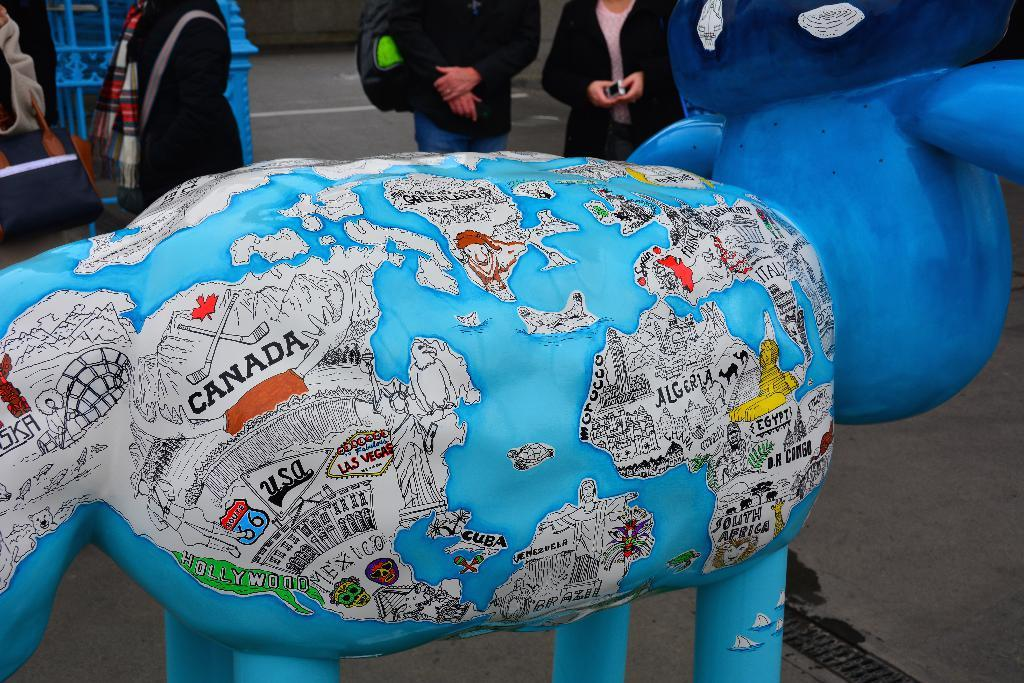What can be observed about the persons in the image? The persons in the image have their faces not visible, and they are wearing clothes. What is the main subject in the middle of the image? There is a statue in the middle of the image. How does the snail contribute to the image? There is no snail present in the image. 